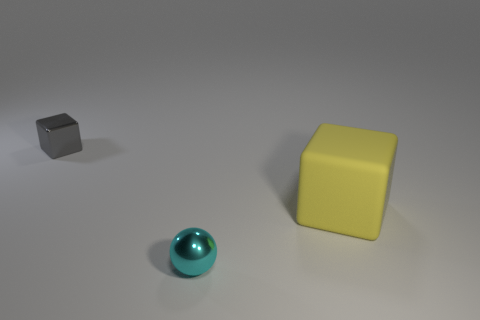Add 2 large cyan metal cylinders. How many objects exist? 5 Subtract 0 brown blocks. How many objects are left? 3 Subtract all spheres. How many objects are left? 2 Subtract all big matte things. Subtract all gray blocks. How many objects are left? 1 Add 3 cyan metal balls. How many cyan metal balls are left? 4 Add 2 purple matte objects. How many purple matte objects exist? 2 